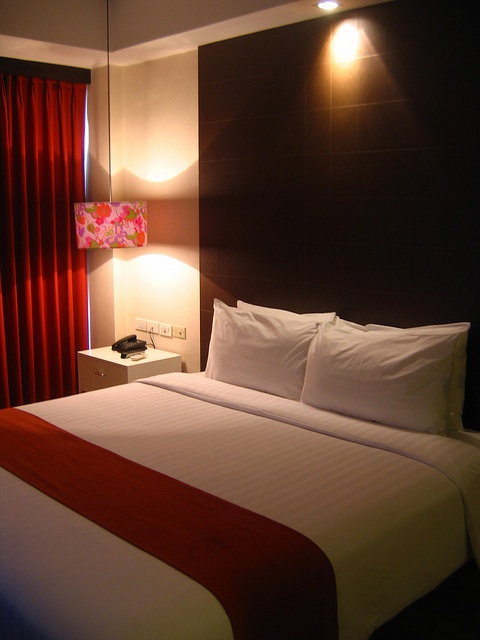Describe the objects in this image and their specific colors. I can see bed in maroon, black, and gray tones, remote in maroon, black, and tan tones, and remote in maroon, tan, and gray tones in this image. 